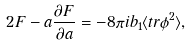Convert formula to latex. <formula><loc_0><loc_0><loc_500><loc_500>2 F - a \frac { \partial F } { \partial a } = - 8 \pi i b _ { 1 } \langle t r \phi ^ { 2 } \rangle ,</formula> 